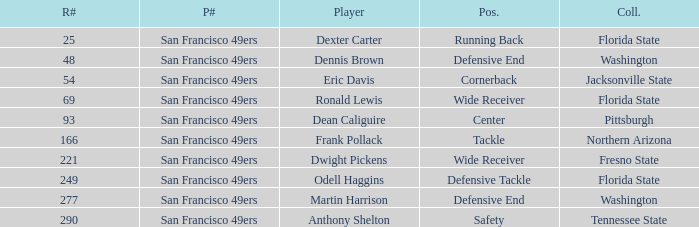What is the College with a Round # that is 290? Tennessee State. 